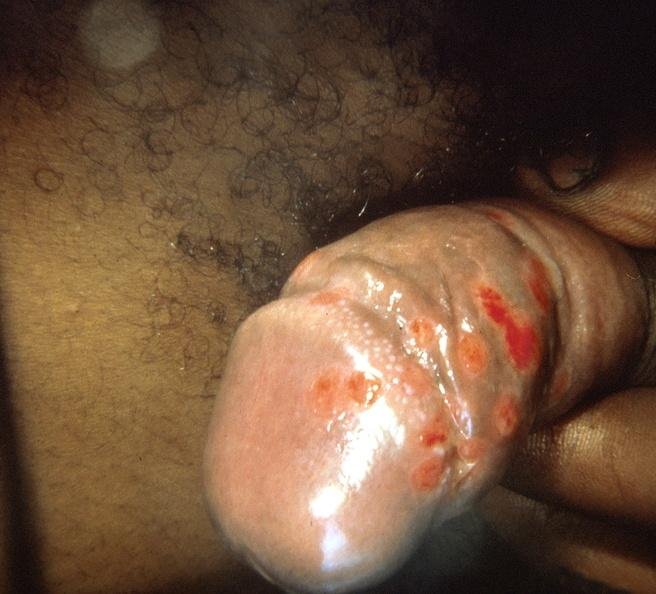does this image show penis, herpes?
Answer the question using a single word or phrase. Yes 